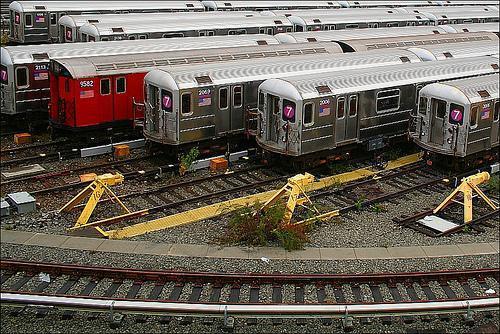How many trains are there?
Give a very brief answer. 9. 